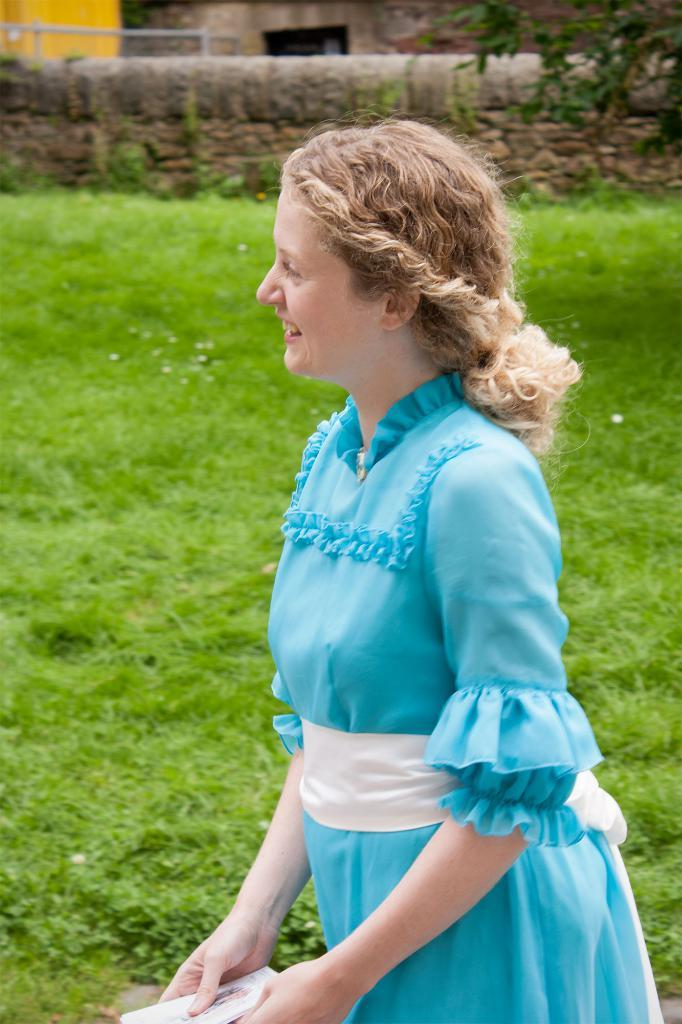Who is present in the image? There is a woman in the image. What is the woman wearing? The woman is wearing a blue dress. What is the woman holding in the image? The woman is holding an object. What can be seen in the background of the image? There is a wall, grass, trees, and a house in the image. What type of list is the woman writing in the image? There is no list or writing activity present in the image. 